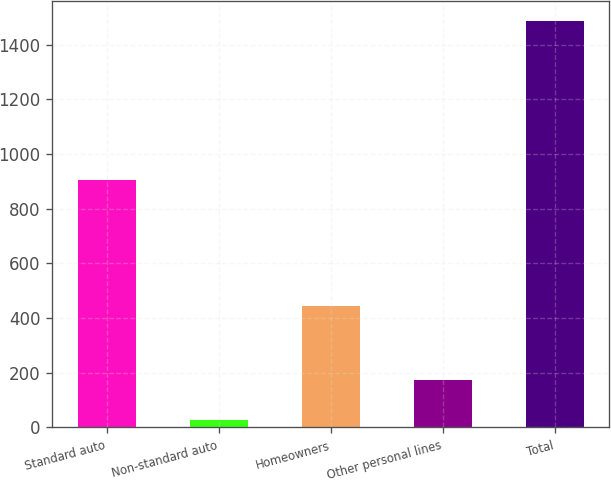Convert chart to OTSL. <chart><loc_0><loc_0><loc_500><loc_500><bar_chart><fcel>Standard auto<fcel>Non-standard auto<fcel>Homeowners<fcel>Other personal lines<fcel>Total<nl><fcel>907<fcel>27<fcel>444<fcel>172.9<fcel>1486<nl></chart> 